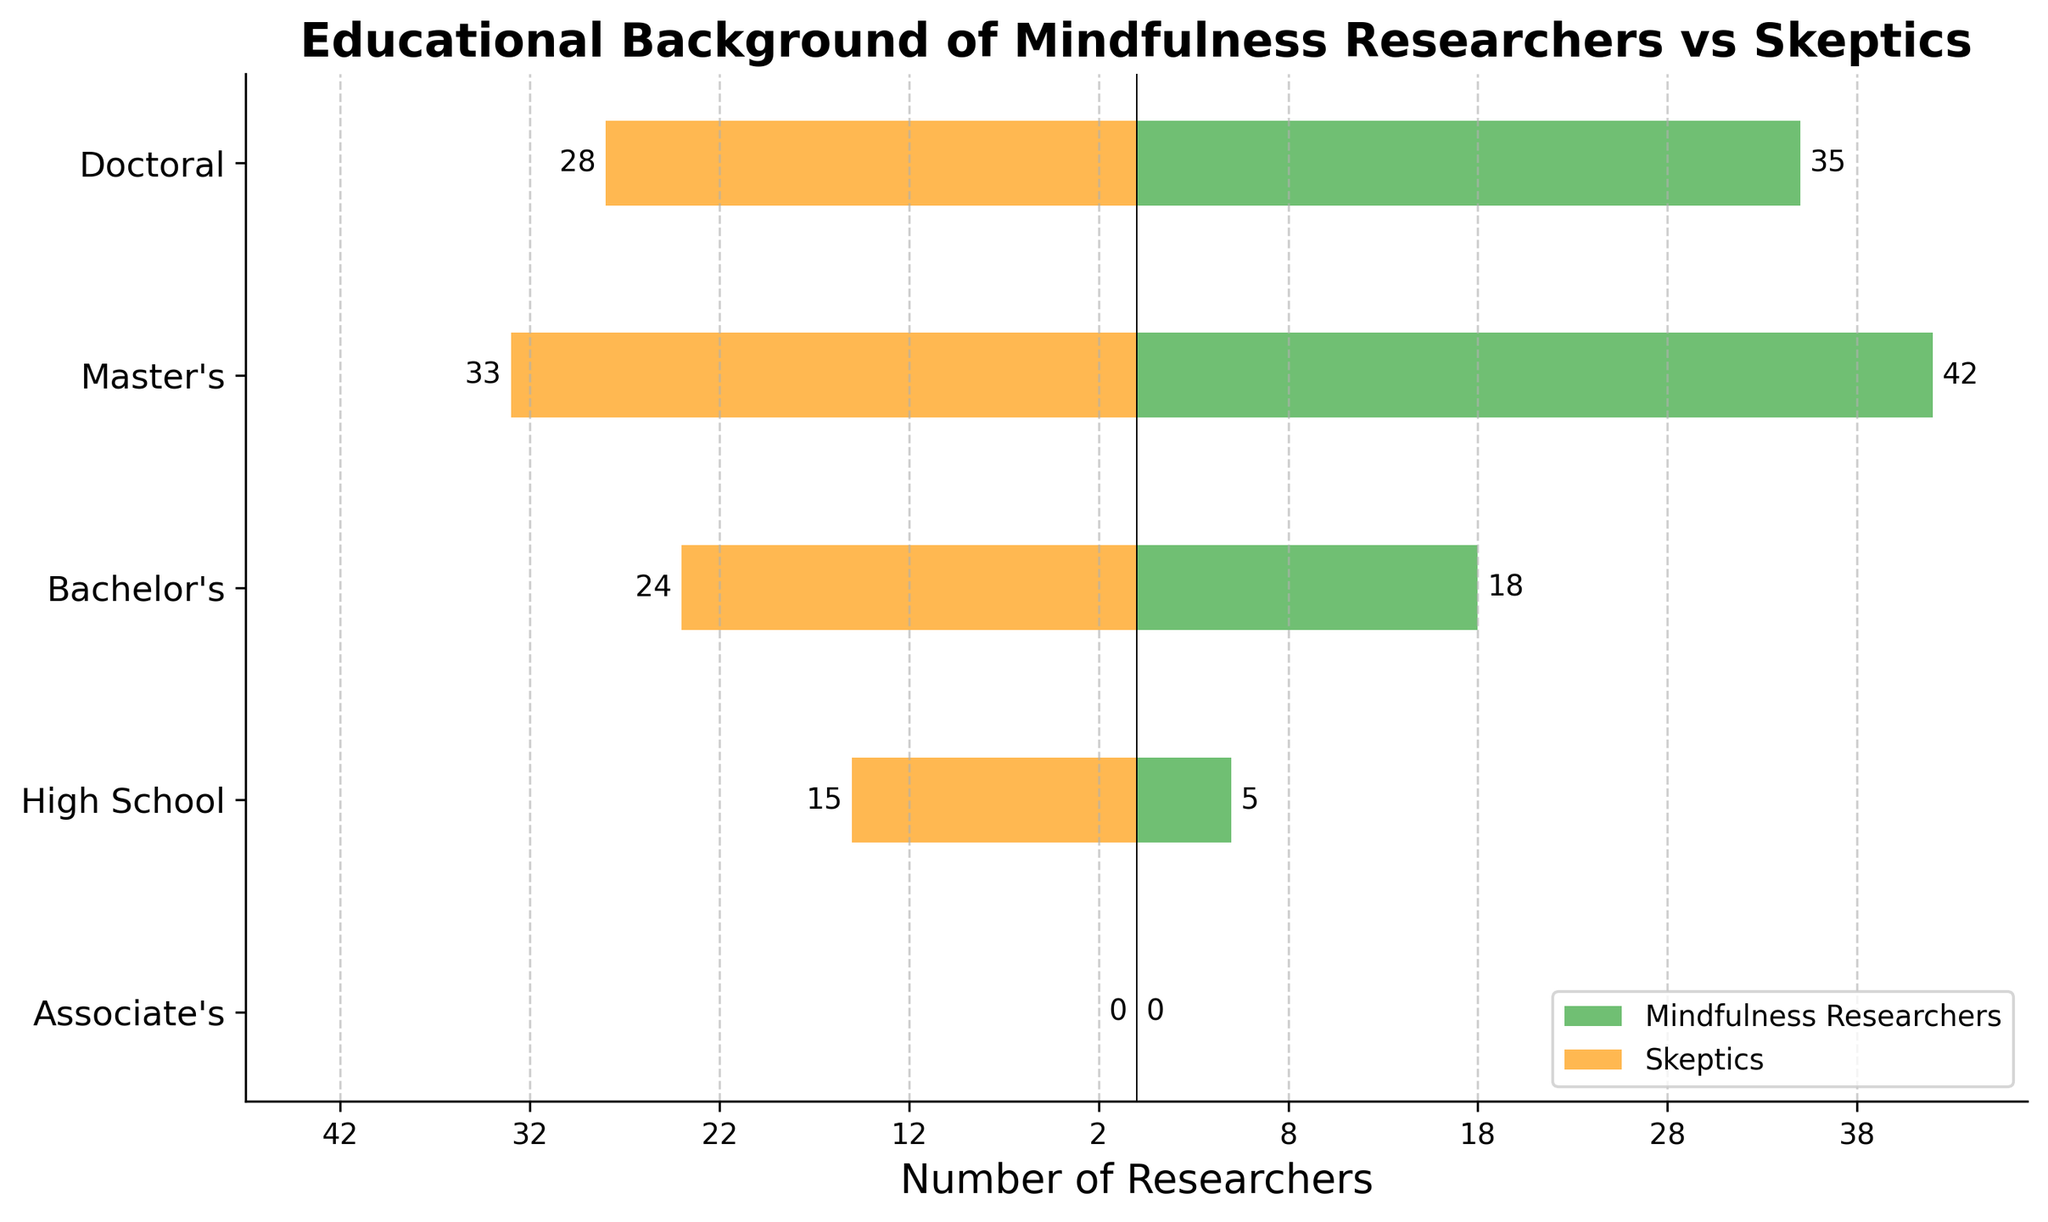What is the educational level with the highest number of mindfulness researchers? The bar for the 'Master's' category is the longest among the mindfulness researchers, indicating it has the highest number of individuals.
Answer: Master's Which group has more people with Bachelor's degrees, mindfulness researchers, or skeptics? Compare the lengths of the 'Bachelor's' bars for both groups. The bar for skeptics is longer than that for mindfulness researchers.
Answer: Skeptics What is the total number of people with Doctoral and Master's degrees among mindfulness researchers? Add the numbers for Doctoral (35) and Master's (42) degrees among mindfulness researchers: 35 + 42 = 77.
Answer: 77 How many more mindfulness researchers have Doctoral degrees compared to those with Bachelor's degrees? Subtract the number of mindfulness researchers with Bachelor's degrees (18) from those with Doctoral degrees (35): 35 - 18 = 17.
Answer: 17 Which educational level shows an equal number of individuals in both groups? The only category that has the same length of bars (0) for both groups is the 'Associate's' degree.
Answer: Associate's Are there more mindfulness researchers or skeptics with High School education? Compare the lengths of the 'High School' bars for both groups. The bar for skeptics is longer than that for mindfulness researchers.
Answer: Skeptics What is the difference in the number of individuals with Master’s degrees between mindfulness researchers and skeptics? Subtract the number of skeptics with Master's degrees (33) from the number of mindfulness researchers with Master's degrees (42): 42 - 33 = 9.
Answer: 9 What percentage of the mindfulness researchers have Doctoral degrees? Divide the number of mindfulness researchers with Doctoral degrees (35) by the total number of mindfulness researchers (100) and multiply by 100: (35 / 100) * 100 = 35%.
Answer: 35% How many total individuals have High School education across both groups? Add the number of mindfulness researchers (5) and skeptics (15) with High School education: 5 + 15 = 20.
Answer: 20 